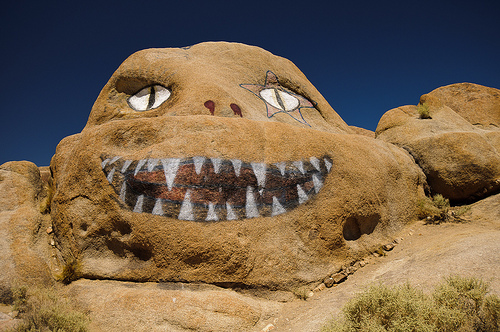<image>
Is the rock on the bush? No. The rock is not positioned on the bush. They may be near each other, but the rock is not supported by or resting on top of the bush. Is the tongue in the rock? Yes. The tongue is contained within or inside the rock, showing a containment relationship. 